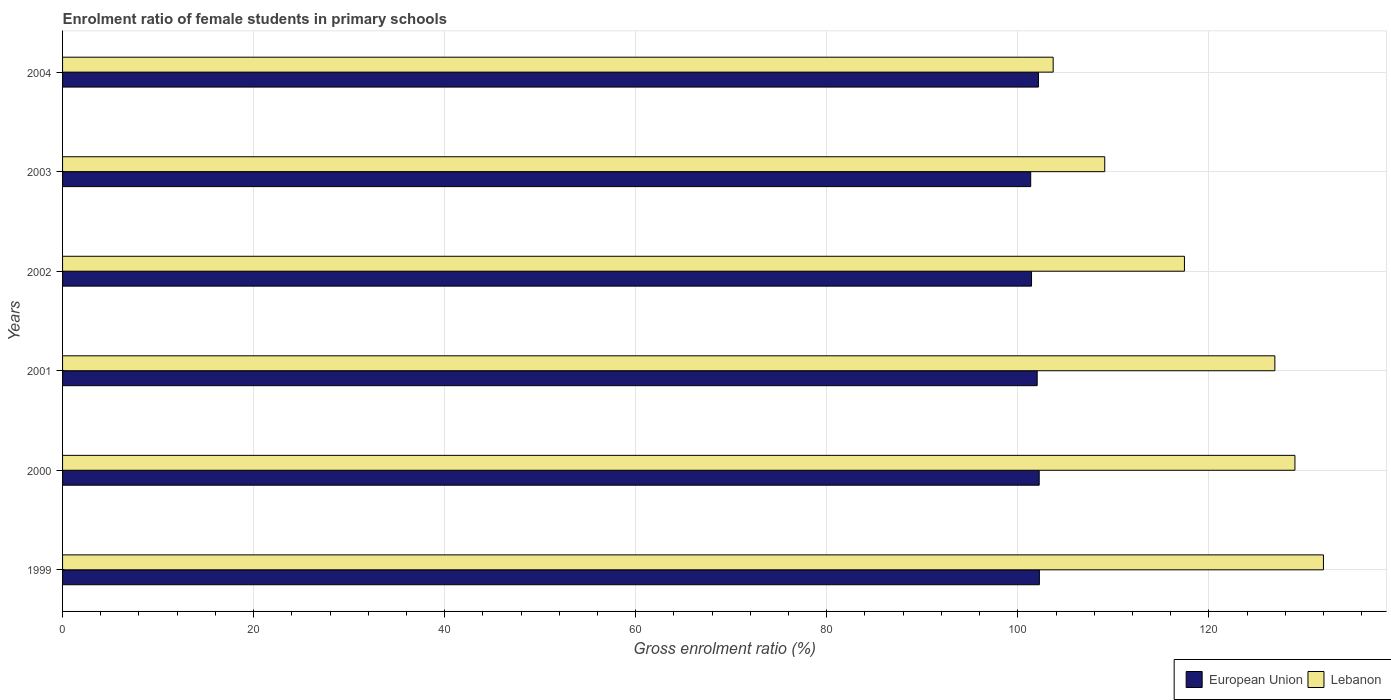How many different coloured bars are there?
Make the answer very short. 2. How many groups of bars are there?
Give a very brief answer. 6. Are the number of bars on each tick of the Y-axis equal?
Give a very brief answer. Yes. How many bars are there on the 5th tick from the top?
Ensure brevity in your answer.  2. What is the label of the 4th group of bars from the top?
Your response must be concise. 2001. What is the enrolment ratio of female students in primary schools in European Union in 2003?
Ensure brevity in your answer.  101.35. Across all years, what is the maximum enrolment ratio of female students in primary schools in European Union?
Provide a short and direct response. 102.26. Across all years, what is the minimum enrolment ratio of female students in primary schools in Lebanon?
Give a very brief answer. 103.71. In which year was the enrolment ratio of female students in primary schools in Lebanon maximum?
Provide a short and direct response. 1999. In which year was the enrolment ratio of female students in primary schools in Lebanon minimum?
Ensure brevity in your answer.  2004. What is the total enrolment ratio of female students in primary schools in European Union in the graph?
Provide a short and direct response. 611.49. What is the difference between the enrolment ratio of female students in primary schools in European Union in 2001 and that in 2002?
Keep it short and to the point. 0.59. What is the difference between the enrolment ratio of female students in primary schools in European Union in 1999 and the enrolment ratio of female students in primary schools in Lebanon in 2001?
Ensure brevity in your answer.  -24.65. What is the average enrolment ratio of female students in primary schools in Lebanon per year?
Offer a very short reply. 119.7. In the year 2001, what is the difference between the enrolment ratio of female students in primary schools in European Union and enrolment ratio of female students in primary schools in Lebanon?
Your answer should be compact. -24.88. What is the ratio of the enrolment ratio of female students in primary schools in Lebanon in 2002 to that in 2003?
Provide a succinct answer. 1.08. Is the enrolment ratio of female students in primary schools in Lebanon in 2001 less than that in 2002?
Offer a terse response. No. Is the difference between the enrolment ratio of female students in primary schools in European Union in 2001 and 2002 greater than the difference between the enrolment ratio of female students in primary schools in Lebanon in 2001 and 2002?
Give a very brief answer. No. What is the difference between the highest and the second highest enrolment ratio of female students in primary schools in European Union?
Provide a succinct answer. 0.02. What is the difference between the highest and the lowest enrolment ratio of female students in primary schools in Lebanon?
Give a very brief answer. 28.29. In how many years, is the enrolment ratio of female students in primary schools in European Union greater than the average enrolment ratio of female students in primary schools in European Union taken over all years?
Ensure brevity in your answer.  4. What does the 1st bar from the top in 2001 represents?
Your answer should be compact. Lebanon. What does the 1st bar from the bottom in 1999 represents?
Provide a short and direct response. European Union. Does the graph contain any zero values?
Offer a very short reply. No. What is the title of the graph?
Make the answer very short. Enrolment ratio of female students in primary schools. What is the Gross enrolment ratio (%) of European Union in 1999?
Provide a short and direct response. 102.26. What is the Gross enrolment ratio (%) of Lebanon in 1999?
Keep it short and to the point. 132. What is the Gross enrolment ratio (%) of European Union in 2000?
Your answer should be very brief. 102.24. What is the Gross enrolment ratio (%) of Lebanon in 2000?
Give a very brief answer. 129.01. What is the Gross enrolment ratio (%) of European Union in 2001?
Offer a terse response. 102.03. What is the Gross enrolment ratio (%) of Lebanon in 2001?
Offer a very short reply. 126.91. What is the Gross enrolment ratio (%) in European Union in 2002?
Provide a short and direct response. 101.44. What is the Gross enrolment ratio (%) in Lebanon in 2002?
Provide a short and direct response. 117.45. What is the Gross enrolment ratio (%) in European Union in 2003?
Ensure brevity in your answer.  101.35. What is the Gross enrolment ratio (%) in Lebanon in 2003?
Offer a terse response. 109.1. What is the Gross enrolment ratio (%) of European Union in 2004?
Offer a terse response. 102.16. What is the Gross enrolment ratio (%) of Lebanon in 2004?
Give a very brief answer. 103.71. Across all years, what is the maximum Gross enrolment ratio (%) in European Union?
Give a very brief answer. 102.26. Across all years, what is the maximum Gross enrolment ratio (%) of Lebanon?
Make the answer very short. 132. Across all years, what is the minimum Gross enrolment ratio (%) of European Union?
Ensure brevity in your answer.  101.35. Across all years, what is the minimum Gross enrolment ratio (%) in Lebanon?
Keep it short and to the point. 103.71. What is the total Gross enrolment ratio (%) in European Union in the graph?
Make the answer very short. 611.49. What is the total Gross enrolment ratio (%) in Lebanon in the graph?
Your answer should be very brief. 718.18. What is the difference between the Gross enrolment ratio (%) of European Union in 1999 and that in 2000?
Your answer should be compact. 0.02. What is the difference between the Gross enrolment ratio (%) of Lebanon in 1999 and that in 2000?
Provide a short and direct response. 2.99. What is the difference between the Gross enrolment ratio (%) in European Union in 1999 and that in 2001?
Give a very brief answer. 0.23. What is the difference between the Gross enrolment ratio (%) in Lebanon in 1999 and that in 2001?
Provide a succinct answer. 5.09. What is the difference between the Gross enrolment ratio (%) of European Union in 1999 and that in 2002?
Your response must be concise. 0.82. What is the difference between the Gross enrolment ratio (%) of Lebanon in 1999 and that in 2002?
Your answer should be very brief. 14.55. What is the difference between the Gross enrolment ratio (%) of European Union in 1999 and that in 2003?
Make the answer very short. 0.91. What is the difference between the Gross enrolment ratio (%) in Lebanon in 1999 and that in 2003?
Offer a very short reply. 22.9. What is the difference between the Gross enrolment ratio (%) of European Union in 1999 and that in 2004?
Provide a short and direct response. 0.1. What is the difference between the Gross enrolment ratio (%) of Lebanon in 1999 and that in 2004?
Keep it short and to the point. 28.29. What is the difference between the Gross enrolment ratio (%) of European Union in 2000 and that in 2001?
Keep it short and to the point. 0.21. What is the difference between the Gross enrolment ratio (%) of Lebanon in 2000 and that in 2001?
Provide a succinct answer. 2.1. What is the difference between the Gross enrolment ratio (%) of European Union in 2000 and that in 2002?
Your response must be concise. 0.8. What is the difference between the Gross enrolment ratio (%) of Lebanon in 2000 and that in 2002?
Your response must be concise. 11.57. What is the difference between the Gross enrolment ratio (%) of European Union in 2000 and that in 2003?
Give a very brief answer. 0.89. What is the difference between the Gross enrolment ratio (%) of Lebanon in 2000 and that in 2003?
Provide a short and direct response. 19.91. What is the difference between the Gross enrolment ratio (%) of European Union in 2000 and that in 2004?
Provide a short and direct response. 0.08. What is the difference between the Gross enrolment ratio (%) in Lebanon in 2000 and that in 2004?
Provide a succinct answer. 25.31. What is the difference between the Gross enrolment ratio (%) in European Union in 2001 and that in 2002?
Your response must be concise. 0.59. What is the difference between the Gross enrolment ratio (%) of Lebanon in 2001 and that in 2002?
Your answer should be compact. 9.47. What is the difference between the Gross enrolment ratio (%) of European Union in 2001 and that in 2003?
Provide a succinct answer. 0.68. What is the difference between the Gross enrolment ratio (%) of Lebanon in 2001 and that in 2003?
Provide a short and direct response. 17.81. What is the difference between the Gross enrolment ratio (%) in European Union in 2001 and that in 2004?
Your response must be concise. -0.13. What is the difference between the Gross enrolment ratio (%) of Lebanon in 2001 and that in 2004?
Your answer should be compact. 23.21. What is the difference between the Gross enrolment ratio (%) of European Union in 2002 and that in 2003?
Provide a short and direct response. 0.09. What is the difference between the Gross enrolment ratio (%) in Lebanon in 2002 and that in 2003?
Give a very brief answer. 8.34. What is the difference between the Gross enrolment ratio (%) of European Union in 2002 and that in 2004?
Offer a terse response. -0.73. What is the difference between the Gross enrolment ratio (%) of Lebanon in 2002 and that in 2004?
Provide a succinct answer. 13.74. What is the difference between the Gross enrolment ratio (%) of European Union in 2003 and that in 2004?
Ensure brevity in your answer.  -0.81. What is the difference between the Gross enrolment ratio (%) of Lebanon in 2003 and that in 2004?
Offer a very short reply. 5.4. What is the difference between the Gross enrolment ratio (%) in European Union in 1999 and the Gross enrolment ratio (%) in Lebanon in 2000?
Offer a very short reply. -26.75. What is the difference between the Gross enrolment ratio (%) of European Union in 1999 and the Gross enrolment ratio (%) of Lebanon in 2001?
Your answer should be very brief. -24.65. What is the difference between the Gross enrolment ratio (%) in European Union in 1999 and the Gross enrolment ratio (%) in Lebanon in 2002?
Your response must be concise. -15.18. What is the difference between the Gross enrolment ratio (%) in European Union in 1999 and the Gross enrolment ratio (%) in Lebanon in 2003?
Make the answer very short. -6.84. What is the difference between the Gross enrolment ratio (%) in European Union in 1999 and the Gross enrolment ratio (%) in Lebanon in 2004?
Make the answer very short. -1.44. What is the difference between the Gross enrolment ratio (%) in European Union in 2000 and the Gross enrolment ratio (%) in Lebanon in 2001?
Keep it short and to the point. -24.67. What is the difference between the Gross enrolment ratio (%) in European Union in 2000 and the Gross enrolment ratio (%) in Lebanon in 2002?
Provide a short and direct response. -15.2. What is the difference between the Gross enrolment ratio (%) of European Union in 2000 and the Gross enrolment ratio (%) of Lebanon in 2003?
Provide a short and direct response. -6.86. What is the difference between the Gross enrolment ratio (%) in European Union in 2000 and the Gross enrolment ratio (%) in Lebanon in 2004?
Your answer should be compact. -1.46. What is the difference between the Gross enrolment ratio (%) of European Union in 2001 and the Gross enrolment ratio (%) of Lebanon in 2002?
Give a very brief answer. -15.41. What is the difference between the Gross enrolment ratio (%) in European Union in 2001 and the Gross enrolment ratio (%) in Lebanon in 2003?
Your answer should be very brief. -7.07. What is the difference between the Gross enrolment ratio (%) in European Union in 2001 and the Gross enrolment ratio (%) in Lebanon in 2004?
Provide a succinct answer. -1.67. What is the difference between the Gross enrolment ratio (%) in European Union in 2002 and the Gross enrolment ratio (%) in Lebanon in 2003?
Your answer should be compact. -7.66. What is the difference between the Gross enrolment ratio (%) in European Union in 2002 and the Gross enrolment ratio (%) in Lebanon in 2004?
Make the answer very short. -2.27. What is the difference between the Gross enrolment ratio (%) in European Union in 2003 and the Gross enrolment ratio (%) in Lebanon in 2004?
Ensure brevity in your answer.  -2.35. What is the average Gross enrolment ratio (%) in European Union per year?
Your answer should be compact. 101.92. What is the average Gross enrolment ratio (%) in Lebanon per year?
Keep it short and to the point. 119.7. In the year 1999, what is the difference between the Gross enrolment ratio (%) of European Union and Gross enrolment ratio (%) of Lebanon?
Make the answer very short. -29.74. In the year 2000, what is the difference between the Gross enrolment ratio (%) of European Union and Gross enrolment ratio (%) of Lebanon?
Provide a short and direct response. -26.77. In the year 2001, what is the difference between the Gross enrolment ratio (%) of European Union and Gross enrolment ratio (%) of Lebanon?
Provide a short and direct response. -24.88. In the year 2002, what is the difference between the Gross enrolment ratio (%) of European Union and Gross enrolment ratio (%) of Lebanon?
Keep it short and to the point. -16.01. In the year 2003, what is the difference between the Gross enrolment ratio (%) in European Union and Gross enrolment ratio (%) in Lebanon?
Offer a terse response. -7.75. In the year 2004, what is the difference between the Gross enrolment ratio (%) in European Union and Gross enrolment ratio (%) in Lebanon?
Your response must be concise. -1.54. What is the ratio of the Gross enrolment ratio (%) in European Union in 1999 to that in 2000?
Your answer should be compact. 1. What is the ratio of the Gross enrolment ratio (%) of Lebanon in 1999 to that in 2000?
Your answer should be compact. 1.02. What is the ratio of the Gross enrolment ratio (%) of European Union in 1999 to that in 2001?
Keep it short and to the point. 1. What is the ratio of the Gross enrolment ratio (%) in Lebanon in 1999 to that in 2001?
Keep it short and to the point. 1.04. What is the ratio of the Gross enrolment ratio (%) of Lebanon in 1999 to that in 2002?
Make the answer very short. 1.12. What is the ratio of the Gross enrolment ratio (%) of European Union in 1999 to that in 2003?
Your answer should be compact. 1.01. What is the ratio of the Gross enrolment ratio (%) in Lebanon in 1999 to that in 2003?
Keep it short and to the point. 1.21. What is the ratio of the Gross enrolment ratio (%) of Lebanon in 1999 to that in 2004?
Your answer should be compact. 1.27. What is the ratio of the Gross enrolment ratio (%) in European Union in 2000 to that in 2001?
Offer a terse response. 1. What is the ratio of the Gross enrolment ratio (%) of Lebanon in 2000 to that in 2001?
Provide a succinct answer. 1.02. What is the ratio of the Gross enrolment ratio (%) of European Union in 2000 to that in 2002?
Ensure brevity in your answer.  1.01. What is the ratio of the Gross enrolment ratio (%) in Lebanon in 2000 to that in 2002?
Offer a very short reply. 1.1. What is the ratio of the Gross enrolment ratio (%) of European Union in 2000 to that in 2003?
Offer a very short reply. 1.01. What is the ratio of the Gross enrolment ratio (%) in Lebanon in 2000 to that in 2003?
Ensure brevity in your answer.  1.18. What is the ratio of the Gross enrolment ratio (%) of Lebanon in 2000 to that in 2004?
Provide a short and direct response. 1.24. What is the ratio of the Gross enrolment ratio (%) of European Union in 2001 to that in 2002?
Make the answer very short. 1.01. What is the ratio of the Gross enrolment ratio (%) in Lebanon in 2001 to that in 2002?
Your answer should be compact. 1.08. What is the ratio of the Gross enrolment ratio (%) in Lebanon in 2001 to that in 2003?
Keep it short and to the point. 1.16. What is the ratio of the Gross enrolment ratio (%) of European Union in 2001 to that in 2004?
Offer a very short reply. 1. What is the ratio of the Gross enrolment ratio (%) in Lebanon in 2001 to that in 2004?
Your answer should be compact. 1.22. What is the ratio of the Gross enrolment ratio (%) in Lebanon in 2002 to that in 2003?
Offer a very short reply. 1.08. What is the ratio of the Gross enrolment ratio (%) in European Union in 2002 to that in 2004?
Keep it short and to the point. 0.99. What is the ratio of the Gross enrolment ratio (%) of Lebanon in 2002 to that in 2004?
Offer a very short reply. 1.13. What is the ratio of the Gross enrolment ratio (%) of European Union in 2003 to that in 2004?
Your answer should be compact. 0.99. What is the ratio of the Gross enrolment ratio (%) in Lebanon in 2003 to that in 2004?
Your answer should be compact. 1.05. What is the difference between the highest and the second highest Gross enrolment ratio (%) of European Union?
Keep it short and to the point. 0.02. What is the difference between the highest and the second highest Gross enrolment ratio (%) in Lebanon?
Your response must be concise. 2.99. What is the difference between the highest and the lowest Gross enrolment ratio (%) in European Union?
Your response must be concise. 0.91. What is the difference between the highest and the lowest Gross enrolment ratio (%) in Lebanon?
Your response must be concise. 28.29. 